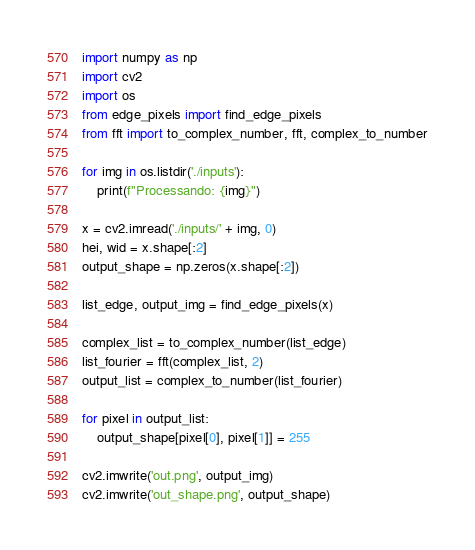<code> <loc_0><loc_0><loc_500><loc_500><_Python_>import numpy as np
import cv2
import os
from edge_pixels import find_edge_pixels
from fft import to_complex_number, fft, complex_to_number

for img in os.listdir('./inputs'):
    print(f"Processando: {img}")

x = cv2.imread('./inputs/' + img, 0)
hei, wid = x.shape[:2]
output_shape = np.zeros(x.shape[:2])

list_edge, output_img = find_edge_pixels(x)

complex_list = to_complex_number(list_edge)
list_fourier = fft(complex_list, 2)
output_list = complex_to_number(list_fourier)

for pixel in output_list:
    output_shape[pixel[0], pixel[1]] = 255

cv2.imwrite('out.png', output_img)
cv2.imwrite('out_shape.png', output_shape)
</code> 